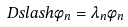Convert formula to latex. <formula><loc_0><loc_0><loc_500><loc_500>\ D s l a s h \phi _ { n } = \lambda _ { n } \phi _ { n }</formula> 